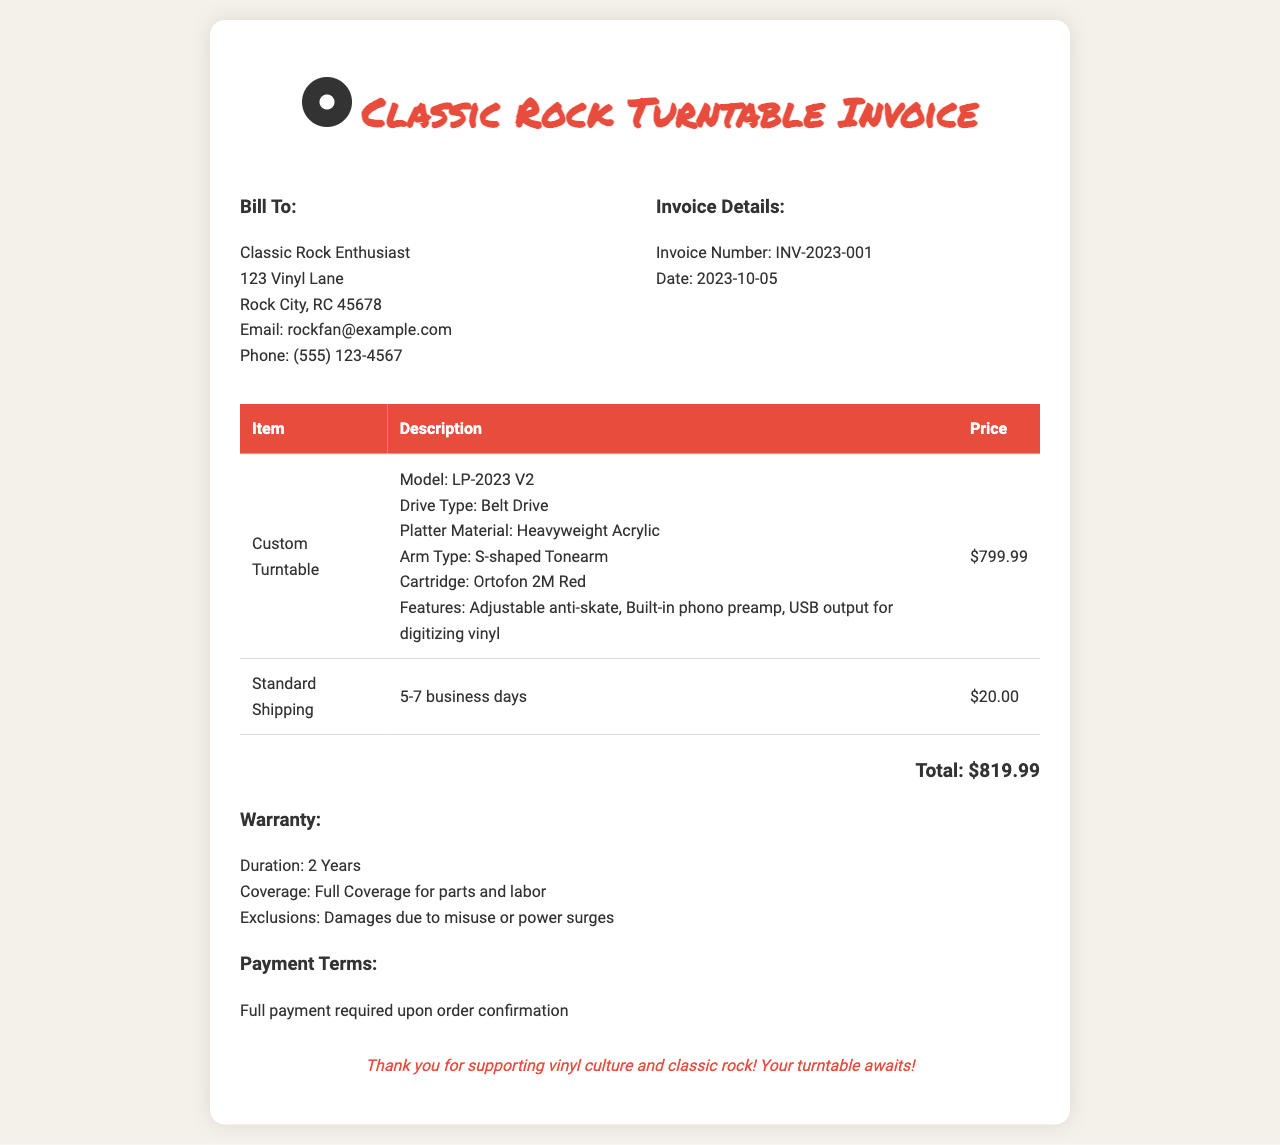What is the model of the custom turntable? The model is specified in the item description of the turntable.
Answer: LP-2023 V2 What is the total cost of the invoice? The total is found at the bottom of the invoice.
Answer: $819.99 What features does the custom turntable include? The features are listed in the description section of the turntable.
Answer: Adjustable anti-skate, Built-in phono preamp, USB output for digitizing vinyl What is the warranty duration for the turntable? The warranty duration is mentioned specifically in the warranty section.
Answer: 2 Years When was the invoice issued? The date of the invoice is provided in the invoice details section.
Answer: 2023-10-05 How much does standard shipping cost? The shipping cost is listed in the table of items.
Answer: $20.00 What payment terms apply to this invoice? Payment terms are outlined in the relevant section of the document.
Answer: Full payment required upon order confirmation What type of drive does the turntable use? The drive type is detailed in the item description of the turntable.
Answer: Belt Drive Is there coverage for parts and labor under the warranty? Warranty coverage details are given in the warranty section.
Answer: Full Coverage for parts and labor 